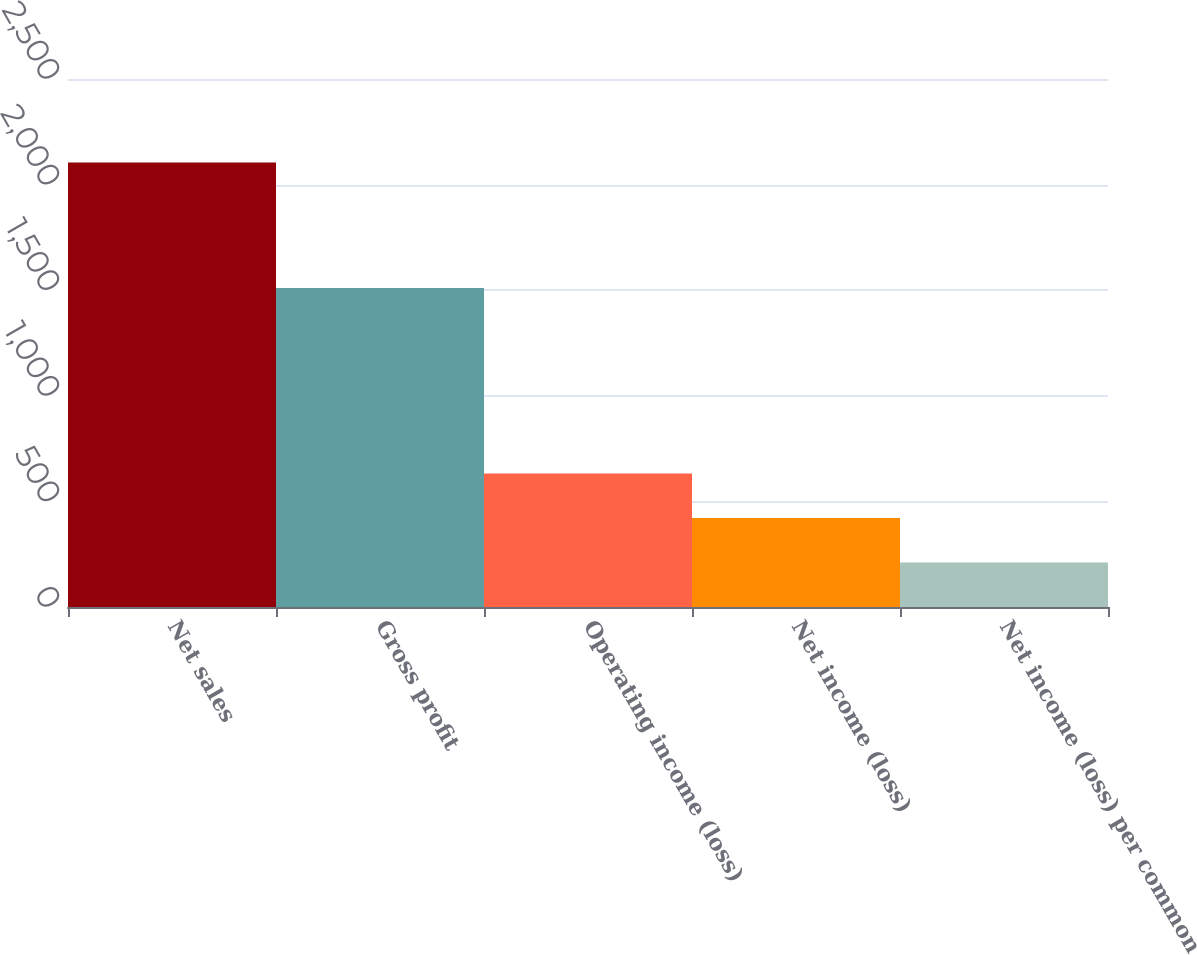<chart> <loc_0><loc_0><loc_500><loc_500><bar_chart><fcel>Net sales<fcel>Gross profit<fcel>Operating income (loss)<fcel>Net income (loss)<fcel>Net income (loss) per common<nl><fcel>2105<fcel>1511<fcel>631.61<fcel>421.13<fcel>210.65<nl></chart> 